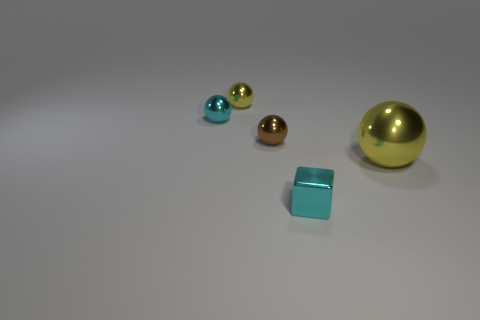Subtract all small balls. How many balls are left? 1 Add 4 small cyan cubes. How many objects exist? 9 Subtract all yellow cylinders. How many yellow balls are left? 2 Subtract all brown spheres. How many spheres are left? 3 Add 3 large red cylinders. How many large red cylinders exist? 3 Subtract 0 yellow cubes. How many objects are left? 5 Subtract all spheres. How many objects are left? 1 Subtract 1 spheres. How many spheres are left? 3 Subtract all red blocks. Subtract all purple spheres. How many blocks are left? 1 Subtract all yellow balls. Subtract all big spheres. How many objects are left? 2 